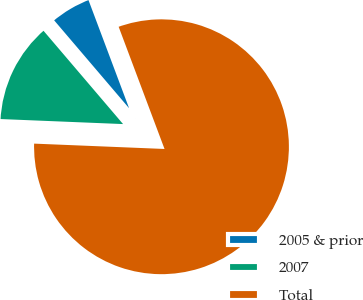Convert chart to OTSL. <chart><loc_0><loc_0><loc_500><loc_500><pie_chart><fcel>2005 & prior<fcel>2007<fcel>Total<nl><fcel>5.52%<fcel>13.11%<fcel>81.37%<nl></chart> 